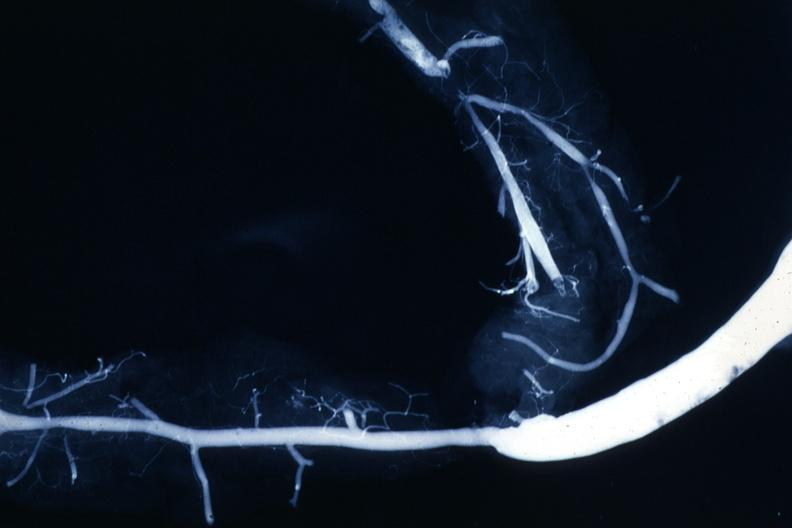s lesion present?
Answer the question using a single word or phrase. No 